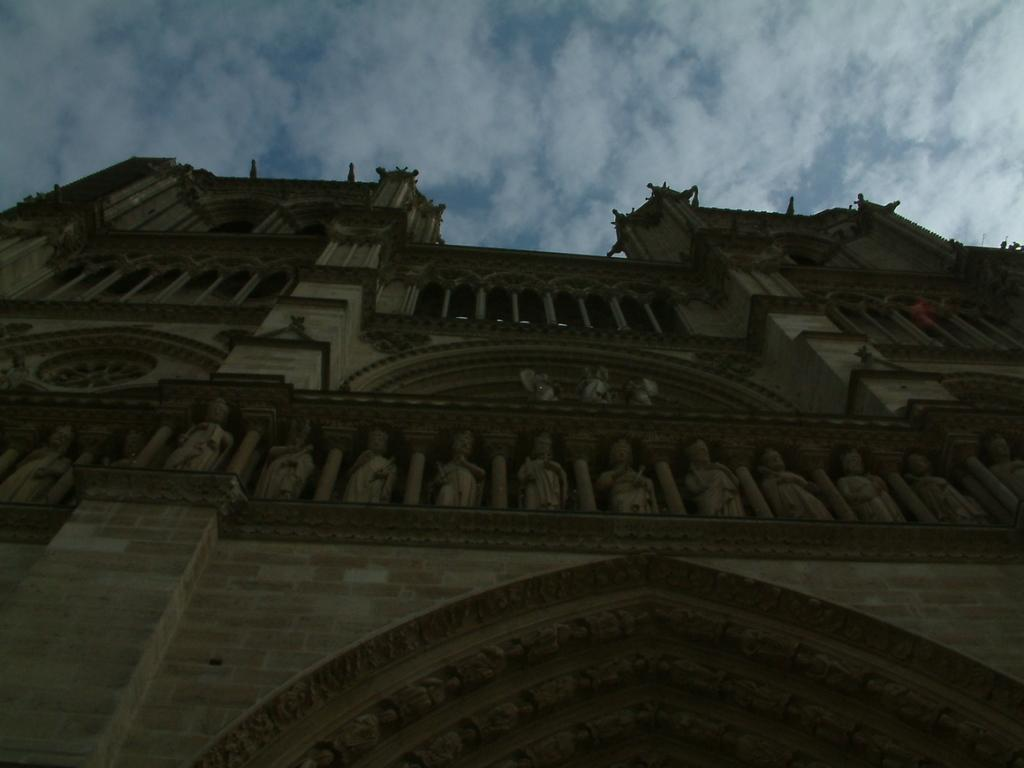What type of structure is present in the image? There is a building in the image. What other objects can be seen in the image besides the building? There are statues in the image. What part of the natural environment is visible in the image? The sky is visible in the image. How would you describe the weather based on the appearance of the sky? The sky appears to be cloudy in the image. What type of flooring is visible in the image? There is no flooring visible in the image, as it primarily features a building, statues, and the sky. 